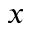Convert formula to latex. <formula><loc_0><loc_0><loc_500><loc_500>x</formula> 